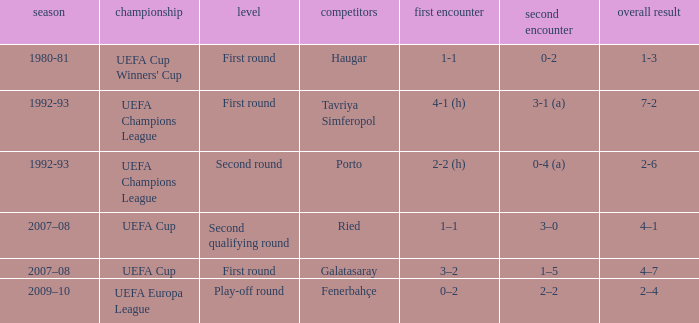 what's the competition where aggregate is 4–7 UEFA Cup. 